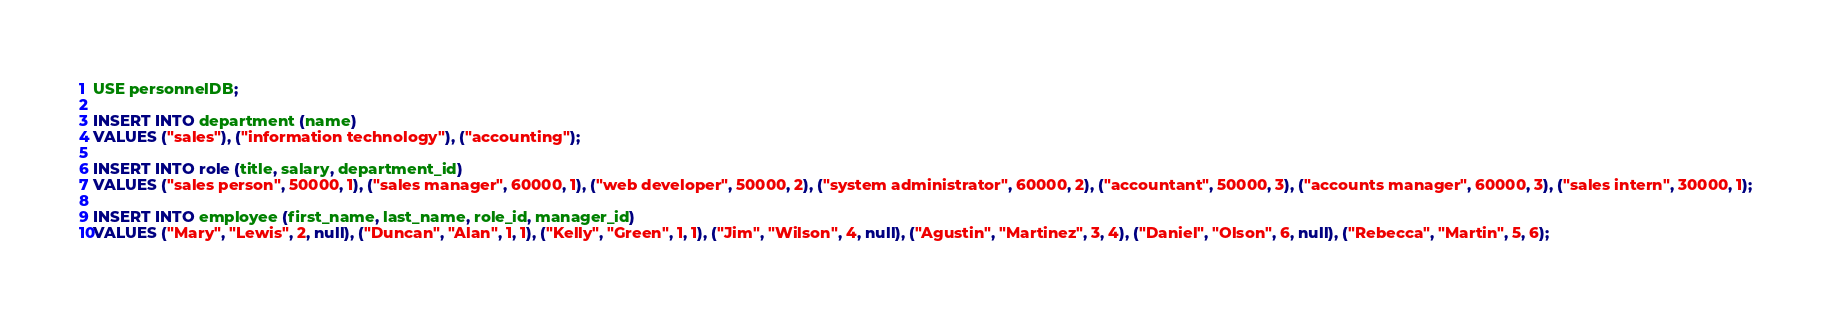Convert code to text. <code><loc_0><loc_0><loc_500><loc_500><_SQL_>USE personnelDB;

INSERT INTO department (name)
VALUES ("sales"), ("information technology"), ("accounting");

INSERT INTO role (title, salary, department_id)
VALUES ("sales person", 50000, 1), ("sales manager", 60000, 1), ("web developer", 50000, 2), ("system administrator", 60000, 2), ("accountant", 50000, 3), ("accounts manager", 60000, 3), ("sales intern", 30000, 1);

INSERT INTO employee (first_name, last_name, role_id, manager_id)
VALUES ("Mary", "Lewis", 2, null), ("Duncan", "Alan", 1, 1), ("Kelly", "Green", 1, 1), ("Jim", "Wilson", 4, null), ("Agustin", "Martinez", 3, 4), ("Daniel", "Olson", 6, null), ("Rebecca", "Martin", 5, 6);
</code> 